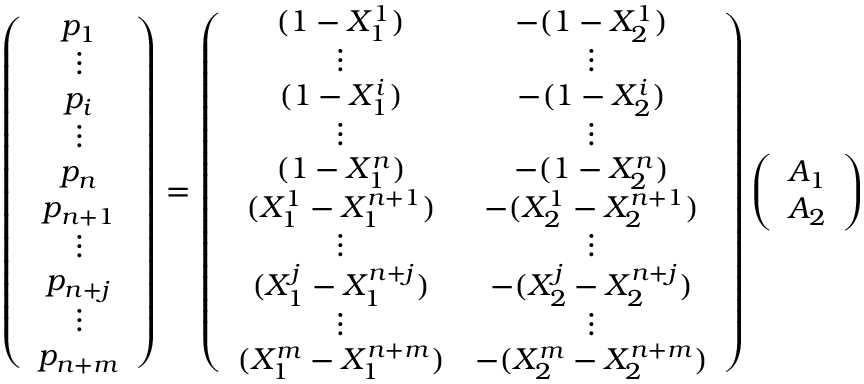<formula> <loc_0><loc_0><loc_500><loc_500>\left ( \begin{array} { c } { p _ { 1 } } \\ { \vdots } \\ { p _ { i } } \\ { \vdots } \\ { p _ { n } } \\ { p _ { n + 1 } } \\ { \vdots } \\ { p _ { n + j } } \\ { \vdots } \\ { p _ { n + m } } \end{array} \right ) = \left ( \begin{array} { c c } { ( 1 - X _ { 1 } ^ { 1 } ) } & { - ( 1 - X _ { 2 } ^ { 1 } ) } \\ { \vdots } & { \vdots } \\ { ( 1 - X _ { 1 } ^ { i } ) } & { - ( 1 - X _ { 2 } ^ { i } ) } \\ { \vdots } & { \vdots } \\ { ( 1 - X _ { 1 } ^ { n } ) } & { - ( 1 - X _ { 2 } ^ { n } ) } \\ { ( X _ { 1 } ^ { 1 } - X _ { 1 } ^ { n + 1 } ) } & { - ( X _ { 2 } ^ { 1 } - X _ { 2 } ^ { n + 1 } ) } \\ { \vdots } & { \vdots } \\ { ( X _ { 1 } ^ { j } - X _ { 1 } ^ { n + j } ) } & { - ( X _ { 2 } ^ { j } - X _ { 2 } ^ { n + j } ) } \\ { \vdots } & { \vdots } \\ { ( X _ { 1 } ^ { m } - X _ { 1 } ^ { n + m } ) } & { - ( X _ { 2 } ^ { m } - X _ { 2 } ^ { n + m } ) } \end{array} \right ) \left ( \begin{array} { c } { A _ { 1 } } \\ { A _ { 2 } } \end{array} \right )</formula> 